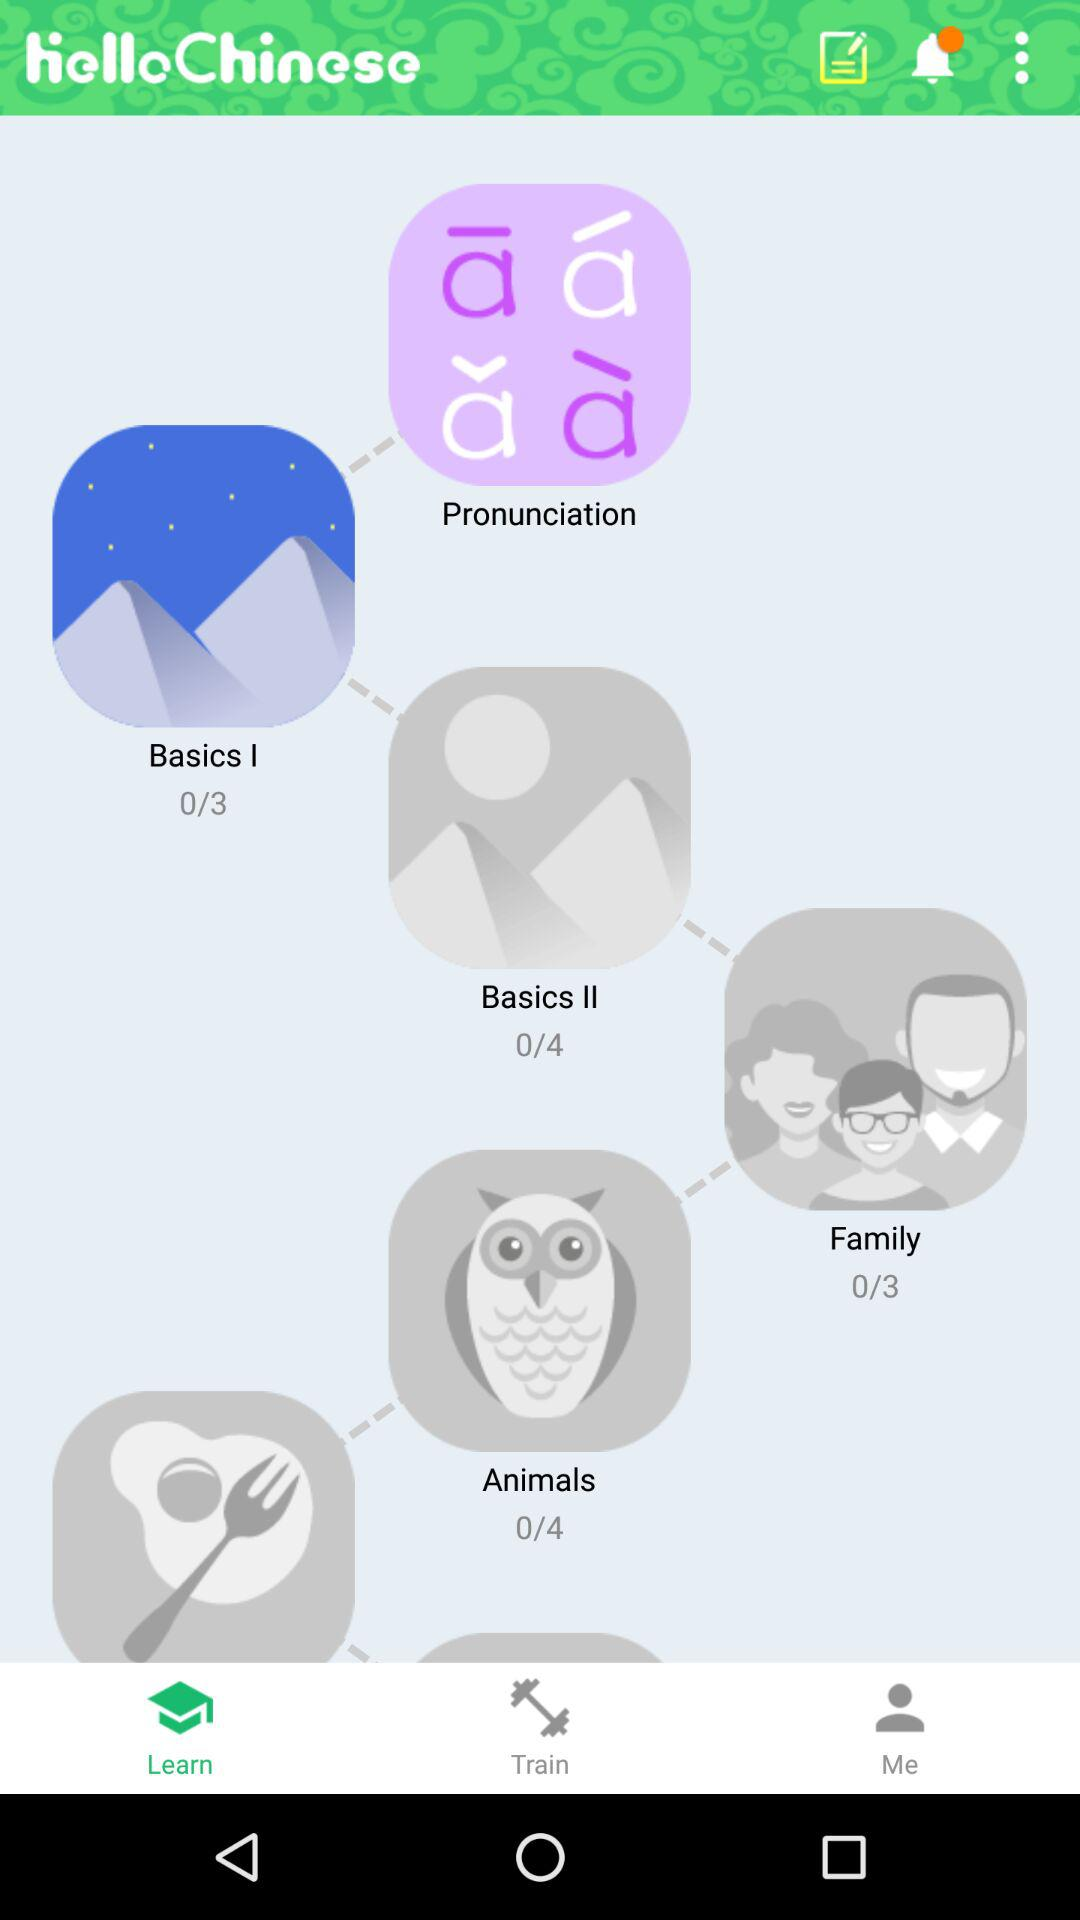Which tab is selected? The selected tab is "Learn". 